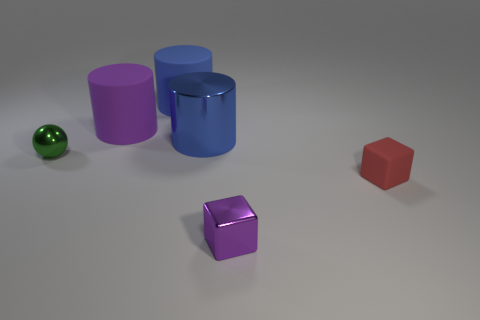There is a metal cylinder; is its color the same as the large matte thing that is right of the big purple rubber cylinder?
Your answer should be very brief. Yes. Are there fewer small green objects in front of the green thing than blue rubber balls?
Make the answer very short. No. What is the large purple cylinder on the left side of the tiny rubber cube made of?
Ensure brevity in your answer.  Rubber. What number of other things are there of the same size as the sphere?
Offer a very short reply. 2. Do the purple shiny thing and the purple cylinder behind the small shiny cube have the same size?
Ensure brevity in your answer.  No. What shape is the tiny object to the left of the big blue cylinder that is behind the metal object that is behind the ball?
Offer a very short reply. Sphere. Is the number of tiny metal spheres less than the number of cylinders?
Keep it short and to the point. Yes. There is a tiny purple thing; are there any green shiny objects left of it?
Offer a very short reply. Yes. What shape is the metallic object that is both left of the tiny purple thing and right of the green metallic ball?
Your response must be concise. Cylinder. Is there a large purple thing of the same shape as the blue metal thing?
Your answer should be very brief. Yes. 